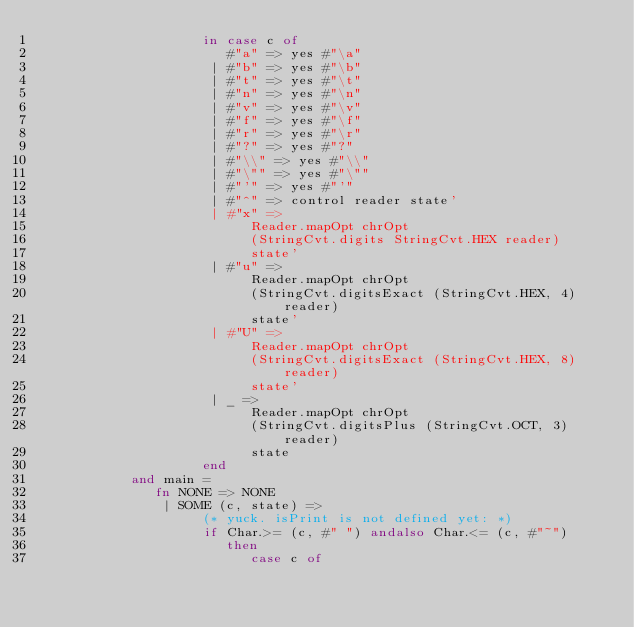Convert code to text. <code><loc_0><loc_0><loc_500><loc_500><_SML_>                     in case c of
                        #"a" => yes #"\a"
                      | #"b" => yes #"\b"
                      | #"t" => yes #"\t"
                      | #"n" => yes #"\n"
                      | #"v" => yes #"\v"
                      | #"f" => yes #"\f"
                      | #"r" => yes #"\r"
                      | #"?" => yes #"?"
                      | #"\\" => yes #"\\"
                      | #"\"" => yes #"\""
                      | #"'" => yes #"'"
                      | #"^" => control reader state'
                      | #"x" =>
                           Reader.mapOpt chrOpt
                           (StringCvt.digits StringCvt.HEX reader)
                           state'
                      | #"u" =>
                           Reader.mapOpt chrOpt
                           (StringCvt.digitsExact (StringCvt.HEX, 4) reader)
                           state'
                      | #"U" =>
                           Reader.mapOpt chrOpt
                           (StringCvt.digitsExact (StringCvt.HEX, 8) reader)
                           state'
                      | _ =>
                           Reader.mapOpt chrOpt
                           (StringCvt.digitsPlus (StringCvt.OCT, 3) reader)
                           state
                     end
            and main =
               fn NONE => NONE
                | SOME (c, state) =>
                     (* yuck. isPrint is not defined yet: *)
                     if Char.>= (c, #" ") andalso Char.<= (c, #"~")
                        then
                           case c of</code> 